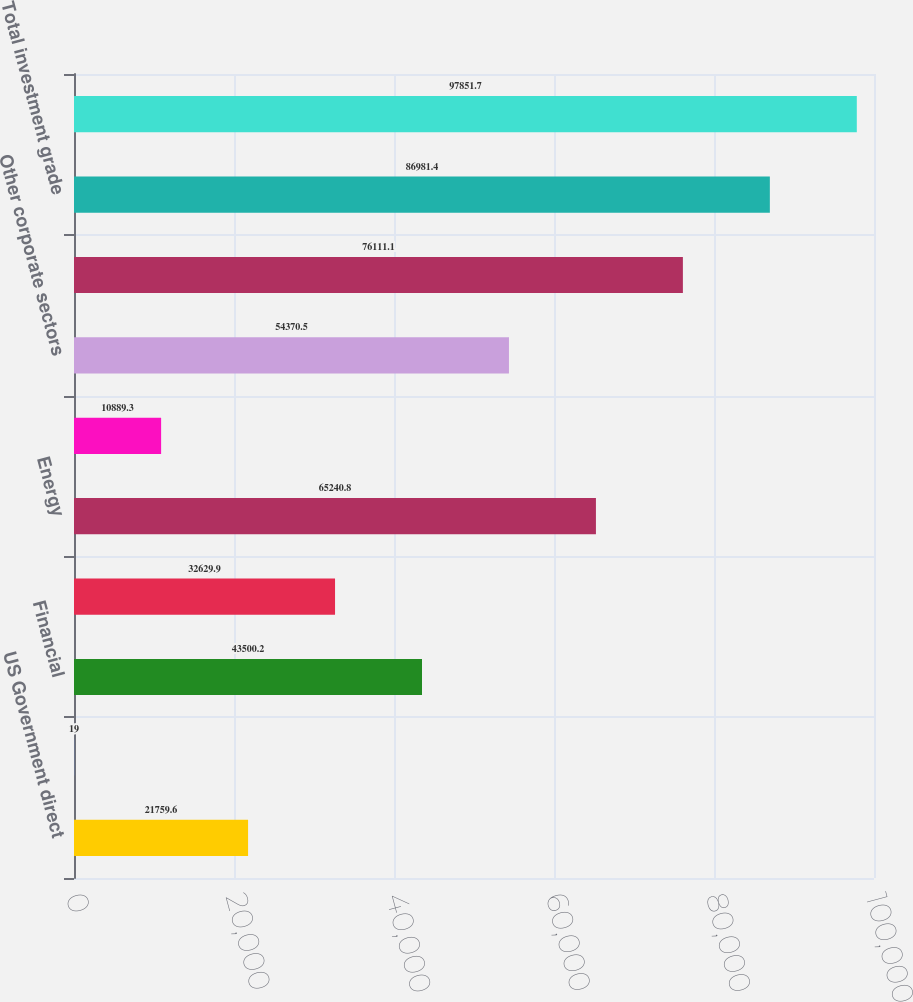Convert chart. <chart><loc_0><loc_0><loc_500><loc_500><bar_chart><fcel>US Government direct<fcel>States municipalities and<fcel>Financial<fcel>Utilities<fcel>Energy<fcel>Metals and mining<fcel>Other corporate sectors<fcel>Total corporates<fcel>Total investment grade<fcel>Total below investment grade<nl><fcel>21759.6<fcel>19<fcel>43500.2<fcel>32629.9<fcel>65240.8<fcel>10889.3<fcel>54370.5<fcel>76111.1<fcel>86981.4<fcel>97851.7<nl></chart> 